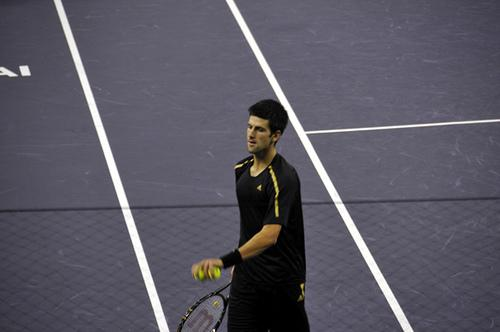What is the person holding in their hands? Please explain your reasoning. tennis balls. A person is on a tennis court, holding a racket, with two yellow, round objects in his hands. 